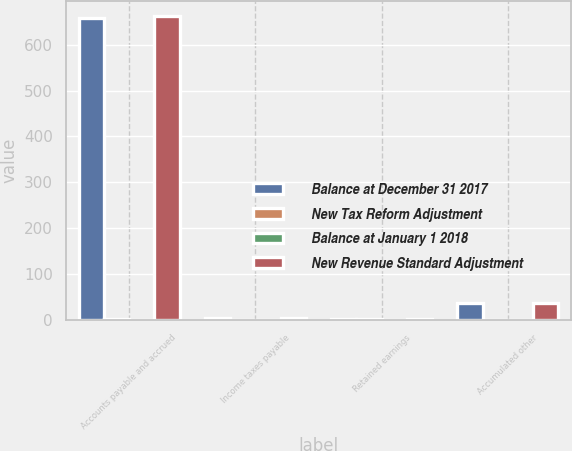<chart> <loc_0><loc_0><loc_500><loc_500><stacked_bar_chart><ecel><fcel>Accounts payable and accrued<fcel>Income taxes payable<fcel>Retained earnings<fcel>Accumulated other<nl><fcel>Balance at December 31 2017<fcel>659.1<fcel>5<fcel>2.65<fcel>36.4<nl><fcel>New Tax Reform Adjustment<fcel>3<fcel>0.7<fcel>2.3<fcel>0<nl><fcel>Balance at January 1 2018<fcel>0<fcel>0<fcel>0.6<fcel>0.6<nl><fcel>New Revenue Standard Adjustment<fcel>662.1<fcel>4.3<fcel>2.65<fcel>37<nl></chart> 